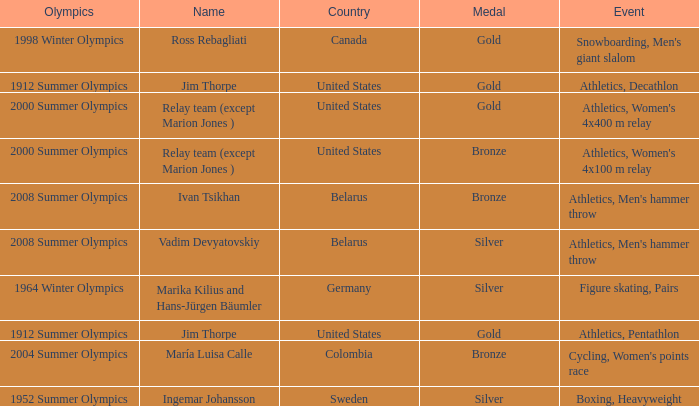What country has a silver medal in the boxing, heavyweight event? Sweden. 